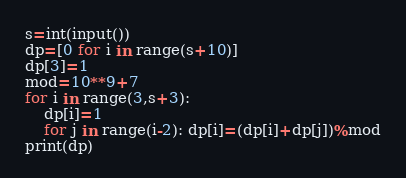<code> <loc_0><loc_0><loc_500><loc_500><_Python_>s=int(input())
dp=[0 for i in range(s+10)]
dp[3]=1
mod=10**9+7
for i in range(3,s+3):
    dp[i]=1
    for j in range(i-2): dp[i]=(dp[i]+dp[j])%mod
print(dp)</code> 